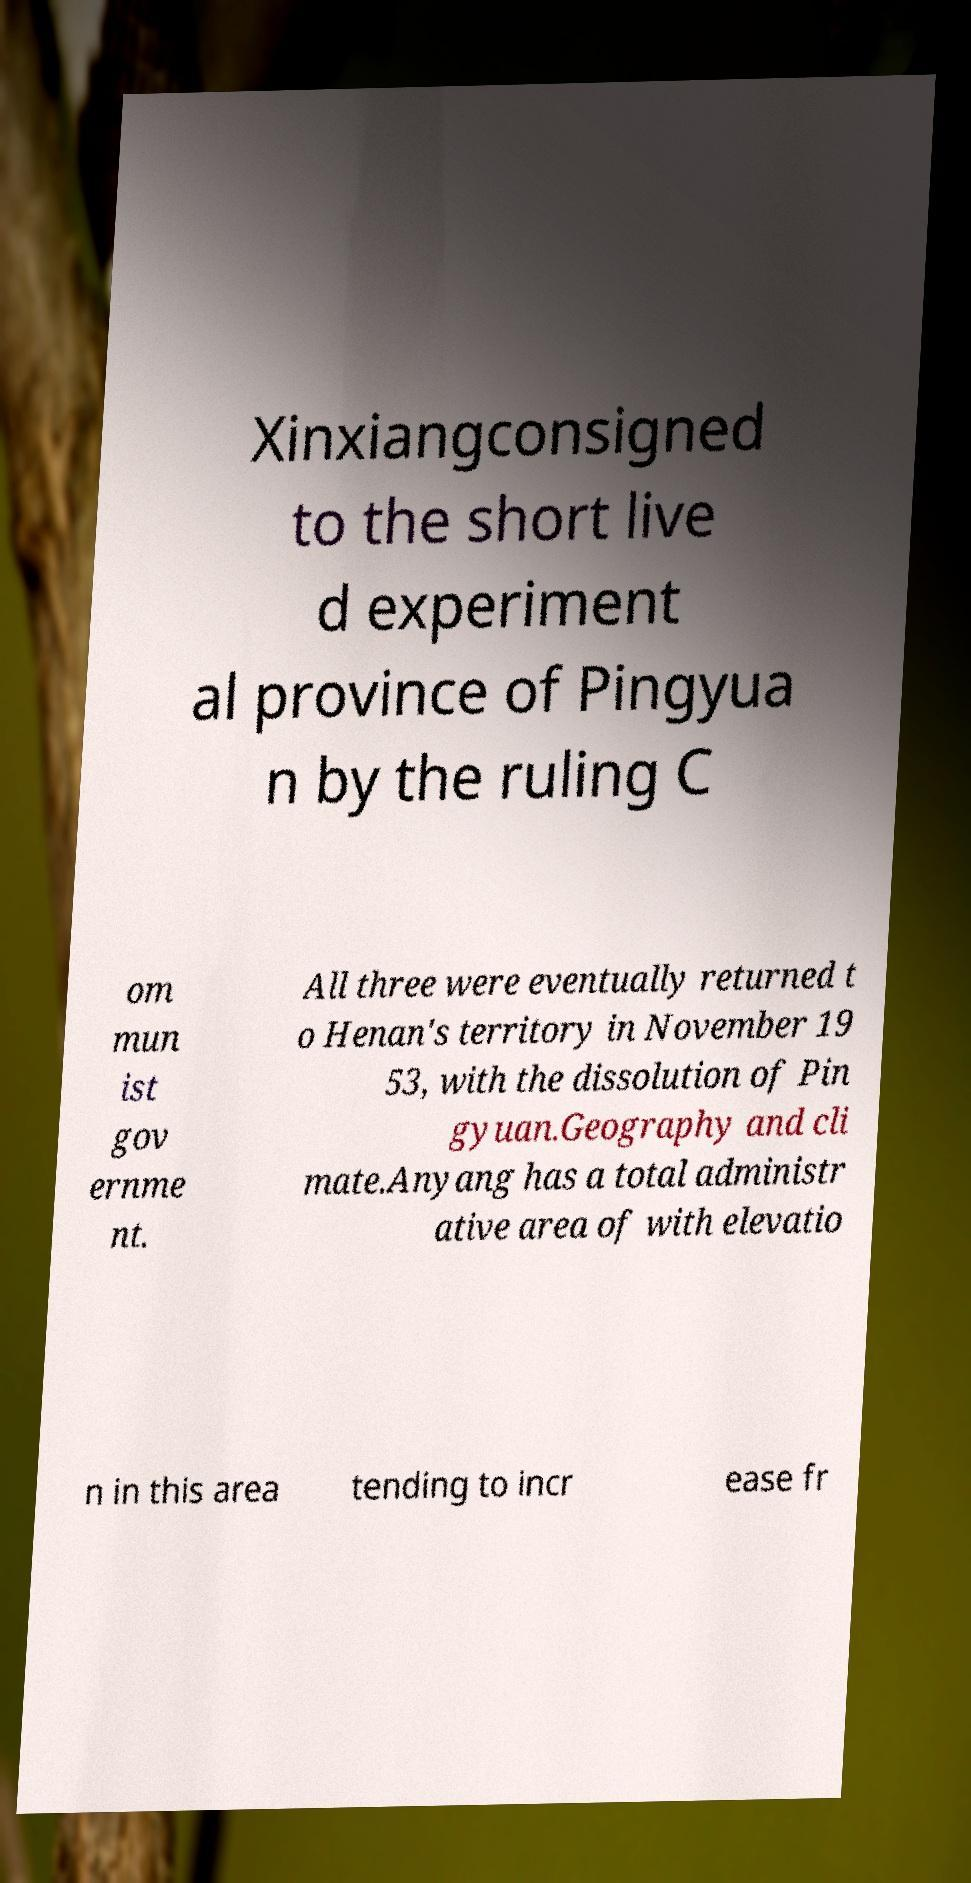For documentation purposes, I need the text within this image transcribed. Could you provide that? Xinxiangconsigned to the short live d experiment al province of Pingyua n by the ruling C om mun ist gov ernme nt. All three were eventually returned t o Henan's territory in November 19 53, with the dissolution of Pin gyuan.Geography and cli mate.Anyang has a total administr ative area of with elevatio n in this area tending to incr ease fr 